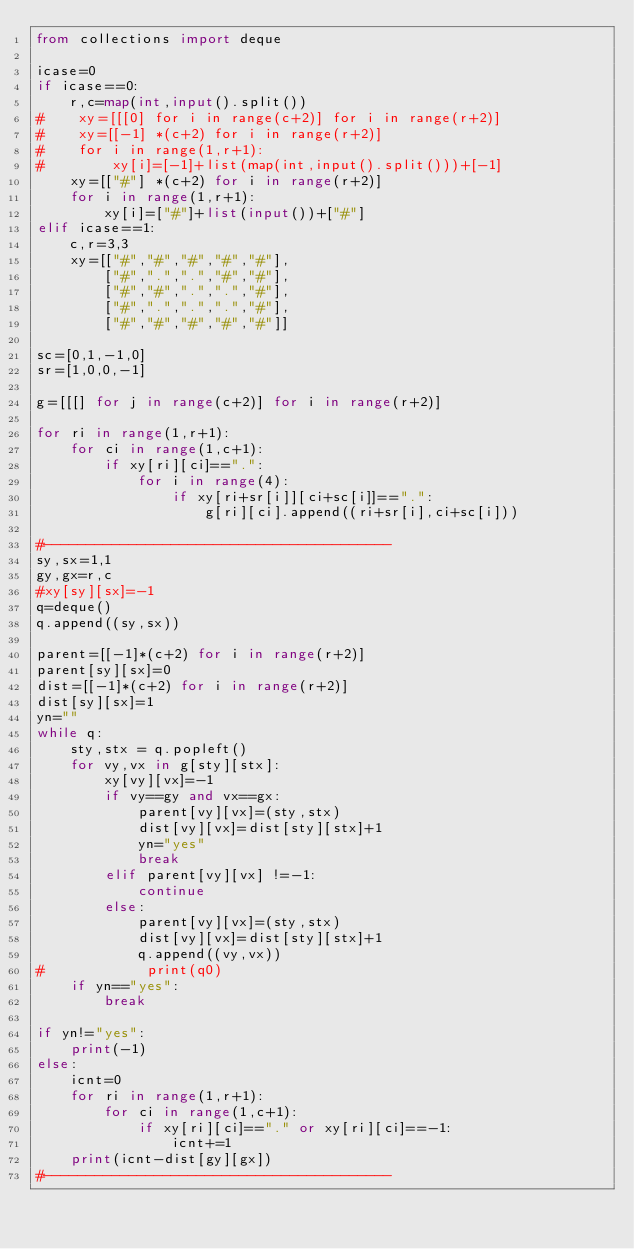Convert code to text. <code><loc_0><loc_0><loc_500><loc_500><_Python_>from collections import deque

icase=0
if icase==0:
    r,c=map(int,input().split())
#    xy=[[[0] for i in range(c+2)] for i in range(r+2)]
#    xy=[[-1] *(c+2) for i in range(r+2)]
#    for i in range(1,r+1):
#        xy[i]=[-1]+list(map(int,input().split()))+[-1]
    xy=[["#"] *(c+2) for i in range(r+2)]
    for i in range(1,r+1):
        xy[i]=["#"]+list(input())+["#"]
elif icase==1:
    c,r=3,3       
    xy=[["#","#","#","#","#"],
        ["#",".",".","#","#"],
        ["#","#",".",".","#"],
        ["#",".",".",".","#"],
        ["#","#","#","#","#"]]

sc=[0,1,-1,0]
sr=[1,0,0,-1]
        
g=[[[] for j in range(c+2)] for i in range(r+2)]

for ri in range(1,r+1):
    for ci in range(1,c+1):
        if xy[ri][ci]==".":
            for i in range(4):
                if xy[ri+sr[i]][ci+sc[i]]==".":
                    g[ri][ci].append((ri+sr[i],ci+sc[i]))

#-----------------------------------------
sy,sx=1,1
gy,gx=r,c
#xy[sy][sx]=-1
q=deque()
q.append((sy,sx))

parent=[[-1]*(c+2) for i in range(r+2)]
parent[sy][sx]=0
dist=[[-1]*(c+2) for i in range(r+2)]
dist[sy][sx]=1
yn=""
while q:
    sty,stx = q.popleft()
    for vy,vx in g[sty][stx]:
        xy[vy][vx]=-1
        if vy==gy and vx==gx:
            parent[vy][vx]=(sty,stx)
            dist[vy][vx]=dist[sty][stx]+1
            yn="yes"
            break
        elif parent[vy][vx] !=-1:
            continue
        else:
            parent[vy][vx]=(sty,stx)
            dist[vy][vx]=dist[sty][stx]+1
            q.append((vy,vx))
#            print(q0)
    if yn=="yes":
        break

if yn!="yes":
    print(-1)
else:
    icnt=0
    for ri in range(1,r+1):
        for ci in range(1,c+1):
            if xy[ri][ci]=="." or xy[ri][ci]==-1:
                icnt+=1
    print(icnt-dist[gy][gx])    
#-----------------------------------------
</code> 